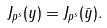<formula> <loc_0><loc_0><loc_500><loc_500>J _ { p ^ { s } } ( y ) = J _ { p ^ { s } } ( \bar { y } ) .</formula> 